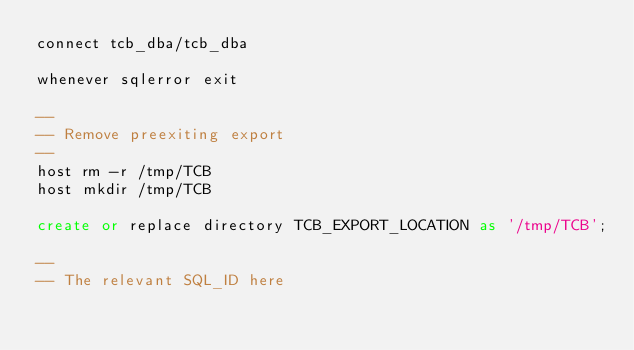Convert code to text. <code><loc_0><loc_0><loc_500><loc_500><_SQL_>connect tcb_dba/tcb_dba

whenever sqlerror exit

--
-- Remove preexiting export
--
host rm -r /tmp/TCB
host mkdir /tmp/TCB

create or replace directory TCB_EXPORT_LOCATION as '/tmp/TCB';

--
-- The relevant SQL_ID here</code> 